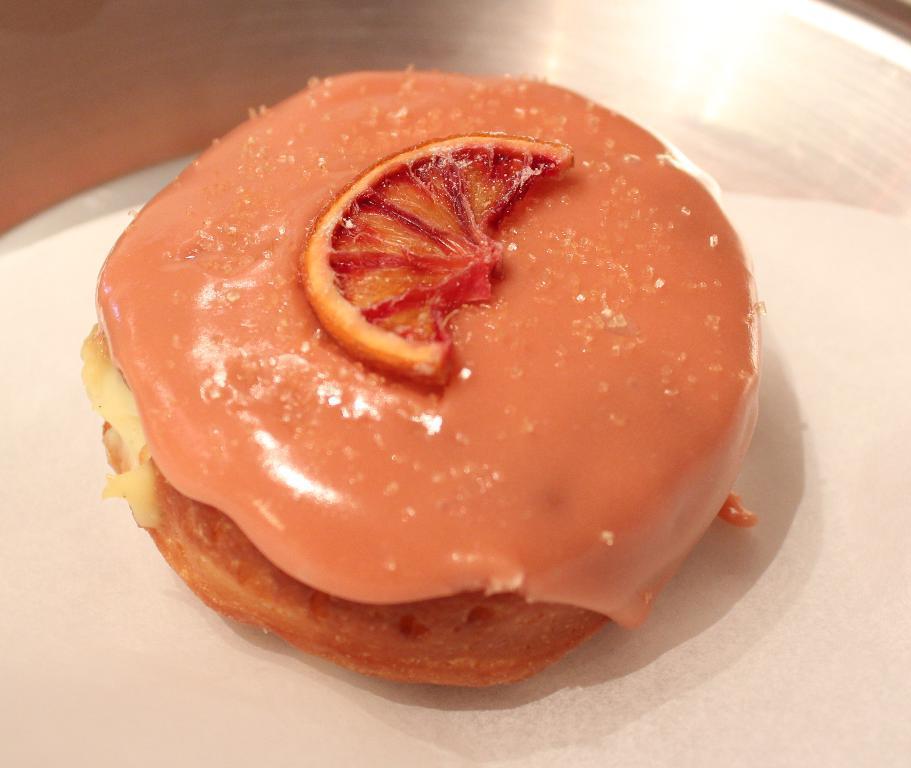Please provide a concise description of this image. In this picture there is a plate, on that table, we can see a plate. On that plate, we can also see some food items which is in orange color. 